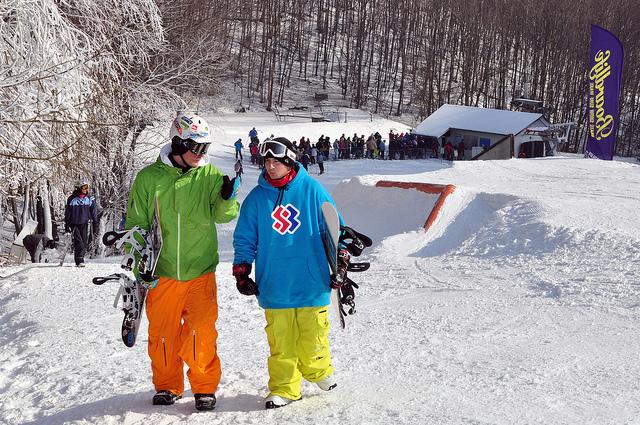How many people are there?
Quick response, please. 50. Are they friends?
Concise answer only. Yes. Where are the boys going?
Write a very short answer. Snowboarding. 